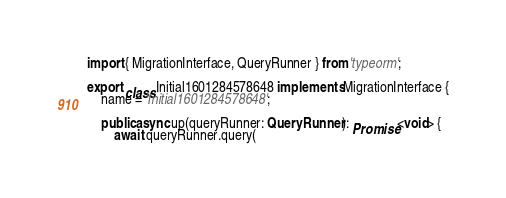<code> <loc_0><loc_0><loc_500><loc_500><_TypeScript_>import { MigrationInterface, QueryRunner } from 'typeorm';

export class Initial1601284578648 implements MigrationInterface {
    name = 'Initial1601284578648';

    public async up(queryRunner: QueryRunner): Promise<void> {
        await queryRunner.query(</code> 